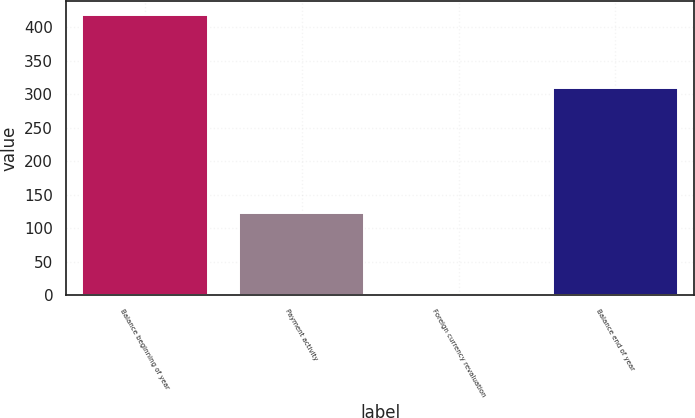Convert chart. <chart><loc_0><loc_0><loc_500><loc_500><bar_chart><fcel>Balance beginning of year<fcel>Payment activity<fcel>Foreign currency revaluation<fcel>Balance end of year<nl><fcel>418<fcel>123<fcel>4<fcel>310<nl></chart> 